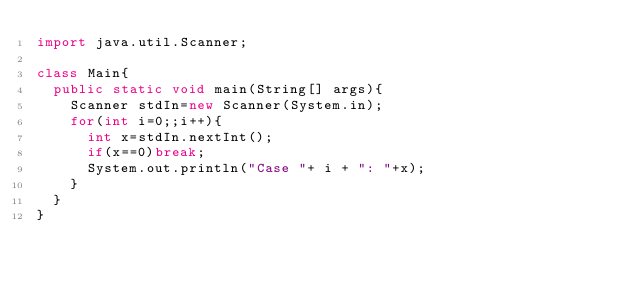Convert code to text. <code><loc_0><loc_0><loc_500><loc_500><_Java_>import java.util.Scanner;

class Main{
	public static void main(String[] args){
		Scanner stdIn=new Scanner(System.in);
		for(int i=0;;i++){
			int x=stdIn.nextInt();
			if(x==0)break;
			System.out.println("Case "+ i + ": "+x);
		}
	}
}</code> 